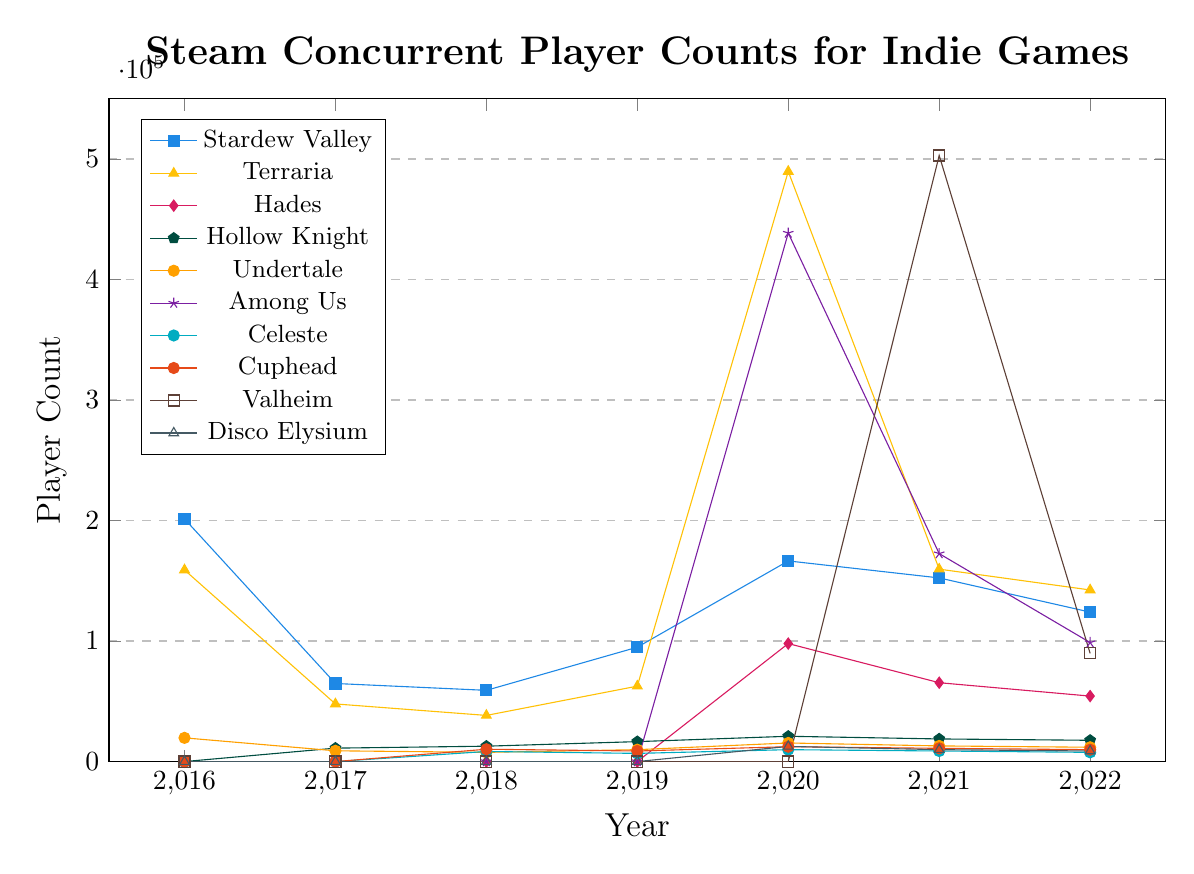what year did Among Us have the highest concurrent player count? The peak for Among Us is represented by the tallest "magenta" line segment, occurring in 2020.
Answer: 2020 Which game had the highest concurrent player count in 2021? The orange-colored line for Valheim reaches the highest peak in 2021, surpassing other games.
Answer: Valheim Compare the concurrent player counts of Stardew Valley and Among Us in 2018. Which one is higher? In 2018, Stardew Valley has a significant player count (59,103), but Among Us has zero concurrent players.
Answer: Stardew Valley Did Hades or Hollow Knight have more concurrent players in 2020? Hades' line intersects at a higher value (97,905) compared to Hollow Knight (20,987) in 2020.
Answer: Hades What is the average concurrent player count for Terraria from 2016 to 2022? The counts for Terraria are (158994, 47821, 38291, 62584, 489645, 159651, 142376). Summing them up gives: 159611 * 10^2 + 235479 * 10^2 / 7 ≈ 151336.
Answer: 151336 Which game showed the most significant drop in concurrent player count from 2020 to 2021? The "magenta" line for Among Us drops sharply from 438,524 to 172,543 between 2020 and 2021.
Answer: Among Us What is the total change in concurrent player count for Stardew Valley from 2016 to 2022? The counts are 201354 - 123987 = 77367
Answer: 77367 Which game has the highest initial player count in 2016? The "blue" line for Stardew Valley starts the highest at 201,354 for 2016.
Answer: Stardew Valley What is the overall trend for Terraria's player count from 2016 to 2022? Initially decreasing from 2016 to 2019, it peaked sharply in 2020, then dropped and stabilized by 2022.
Answer: Decrease-Peak-Stabilize 